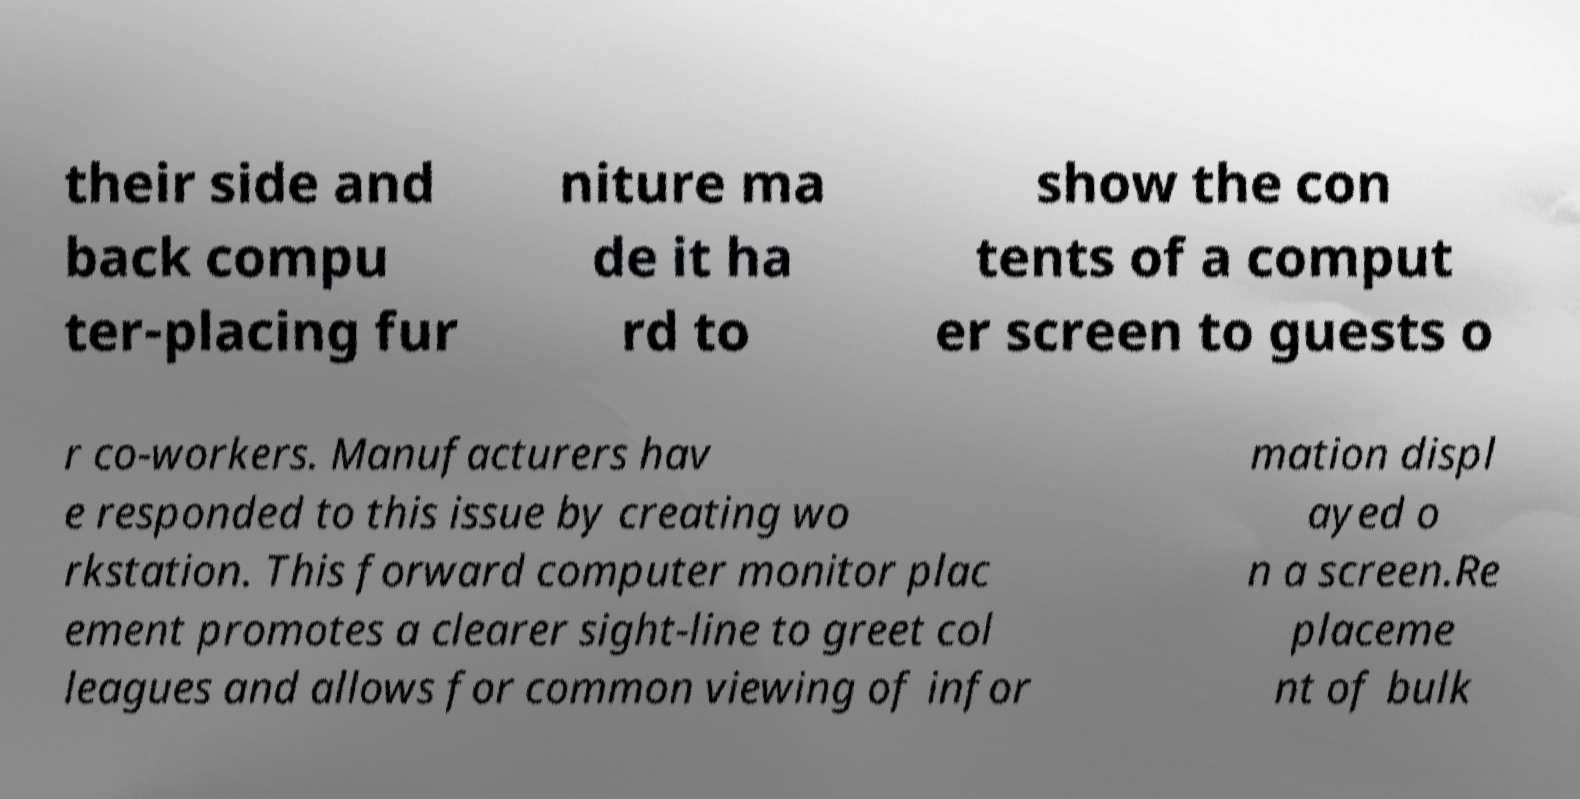What messages or text are displayed in this image? I need them in a readable, typed format. their side and back compu ter-placing fur niture ma de it ha rd to show the con tents of a comput er screen to guests o r co-workers. Manufacturers hav e responded to this issue by creating wo rkstation. This forward computer monitor plac ement promotes a clearer sight-line to greet col leagues and allows for common viewing of infor mation displ ayed o n a screen.Re placeme nt of bulk 